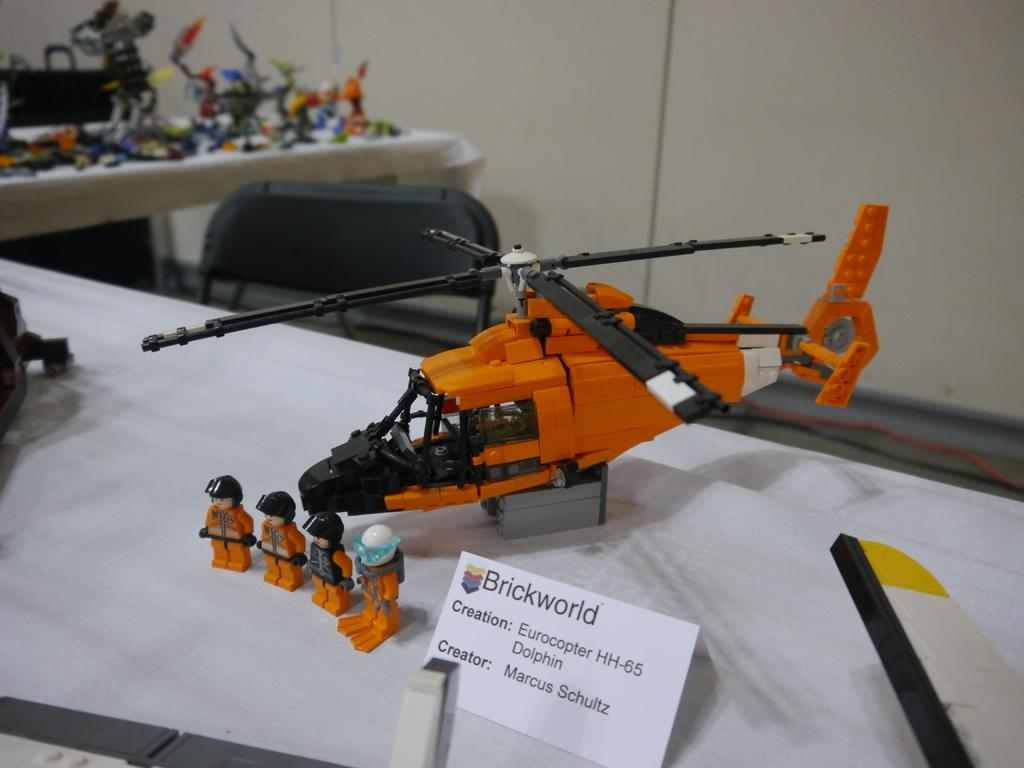<image>
Create a compact narrative representing the image presented. The helicopter model is a Eurocopter HH-65 Dolphin, which was created by Marcus Schultz of Brickworld. 